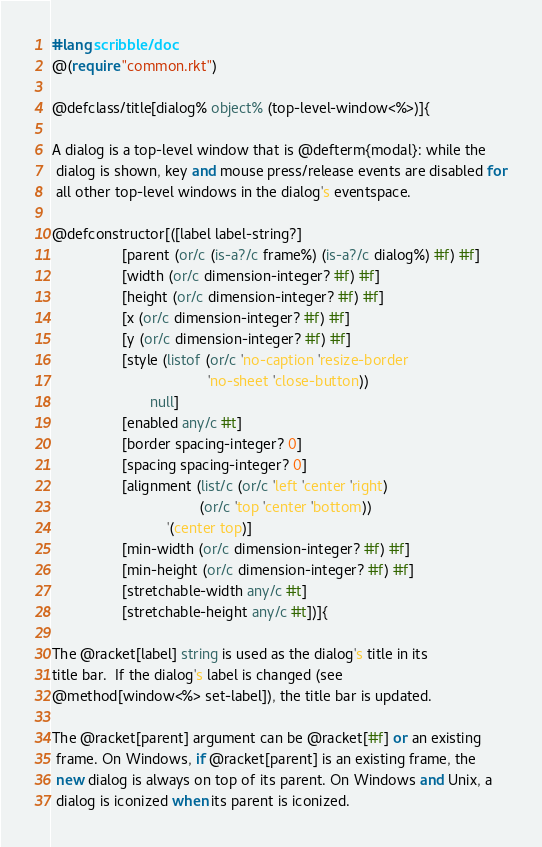Convert code to text. <code><loc_0><loc_0><loc_500><loc_500><_Racket_>#lang scribble/doc
@(require "common.rkt")

@defclass/title[dialog% object% (top-level-window<%>)]{

A dialog is a top-level window that is @defterm{modal}: while the
 dialog is shown, key and mouse press/release events are disabled for
 all other top-level windows in the dialog's eventspace.

@defconstructor[([label label-string?]
                 [parent (or/c (is-a?/c frame%) (is-a?/c dialog%) #f) #f]
                 [width (or/c dimension-integer? #f) #f]
                 [height (or/c dimension-integer? #f) #f]
                 [x (or/c dimension-integer? #f) #f]
                 [y (or/c dimension-integer? #f) #f]
                 [style (listof (or/c 'no-caption 'resize-border 
                                      'no-sheet 'close-button)) 
                        null]
                 [enabled any/c #t]
                 [border spacing-integer? 0]
                 [spacing spacing-integer? 0]
                 [alignment (list/c (or/c 'left 'center 'right)
                                    (or/c 'top 'center 'bottom))
                            '(center top)]
                 [min-width (or/c dimension-integer? #f) #f]
                 [min-height (or/c dimension-integer? #f) #f]
                 [stretchable-width any/c #t]
                 [stretchable-height any/c #t])]{

The @racket[label] string is used as the dialog's title in its
title bar.  If the dialog's label is changed (see
@method[window<%> set-label]), the title bar is updated.

The @racket[parent] argument can be @racket[#f] or an existing
 frame. On Windows, if @racket[parent] is an existing frame, the
 new dialog is always on top of its parent. On Windows and Unix, a
 dialog is iconized when its parent is iconized.
</code> 